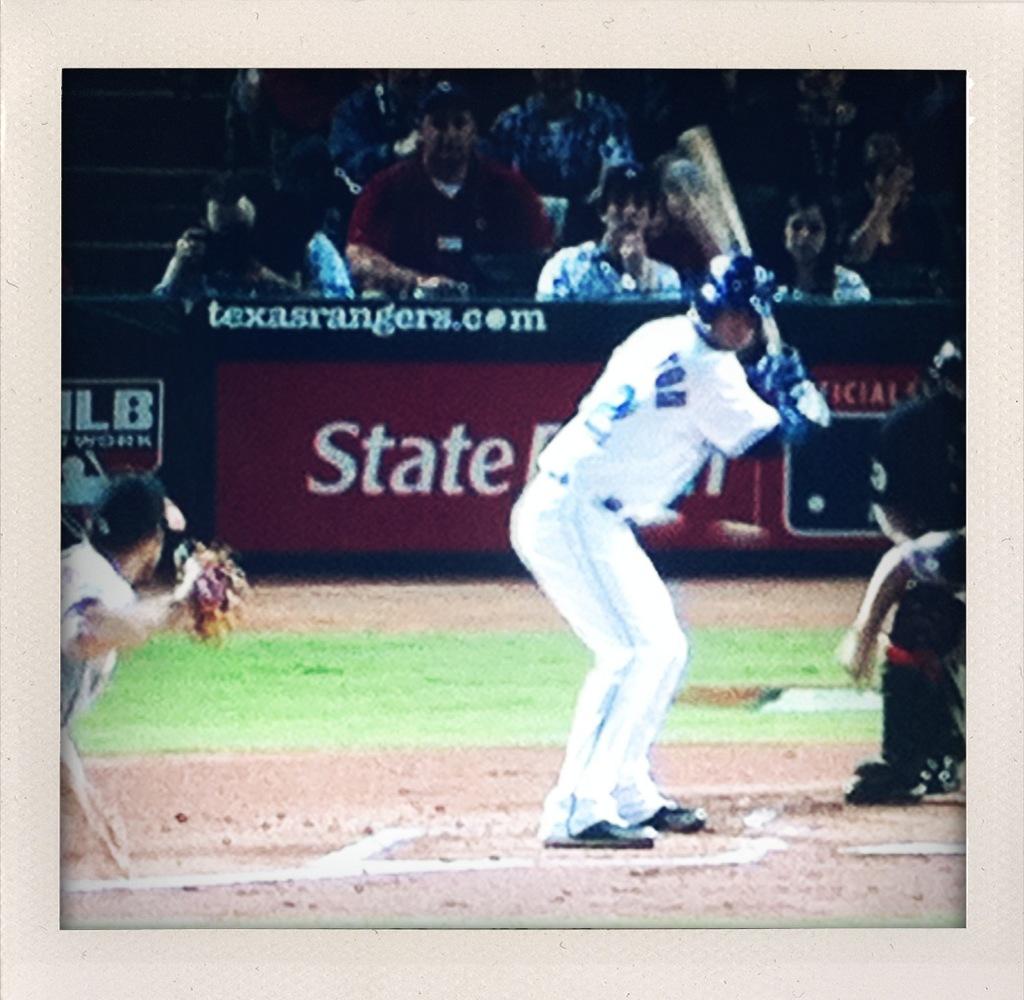Is there a website i can go to, to learn more about the team?
Your response must be concise. Texasrangers.com. Which team is playing?
Give a very brief answer. Texas rangers. 